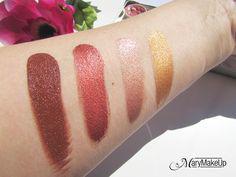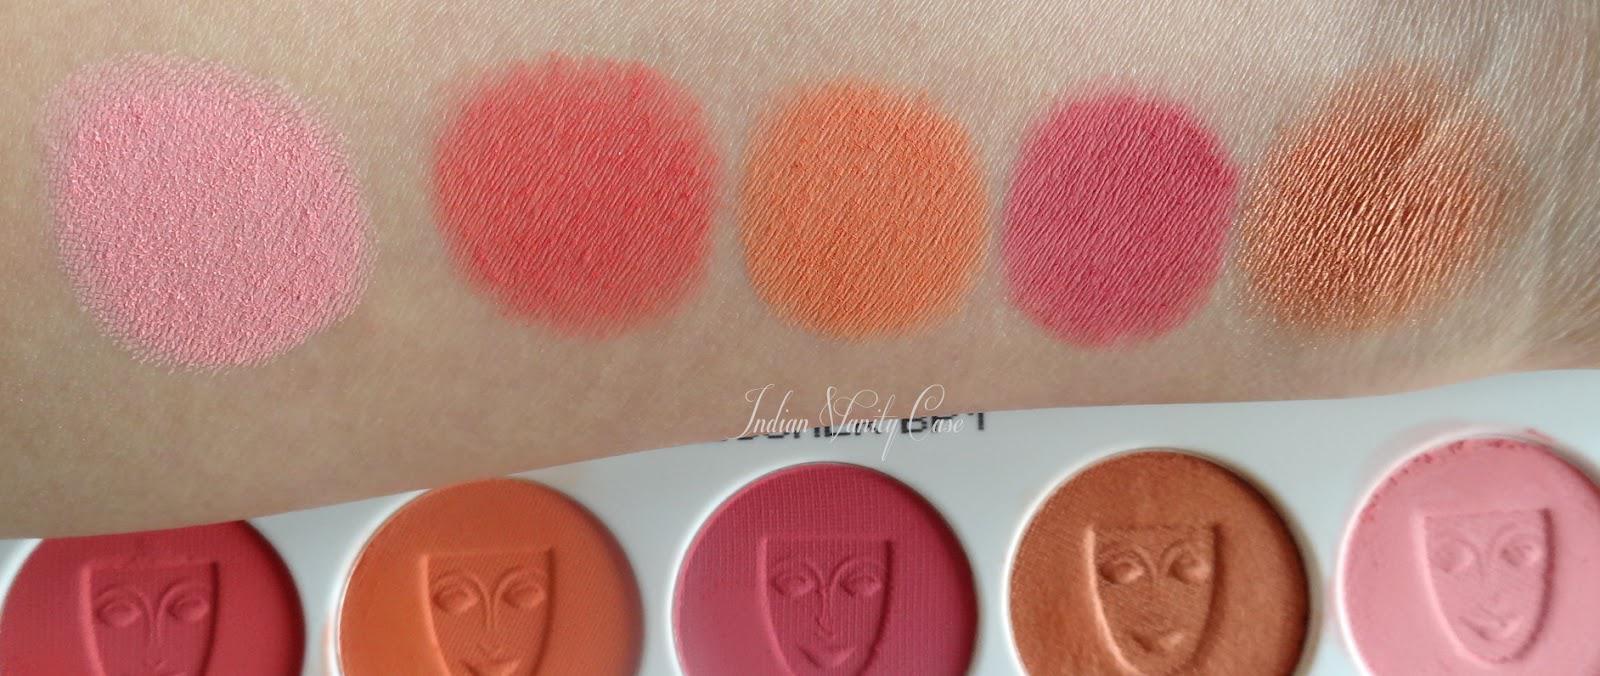The first image is the image on the left, the second image is the image on the right. Analyze the images presented: Is the assertion "Each image shows lipstick stripe marks on pale skin displayed vertically, and each image includes at least five different stripes of color." valid? Answer yes or no. No. The first image is the image on the left, the second image is the image on the right. Considering the images on both sides, is "One arm has 4 swatches on it." valid? Answer yes or no. Yes. 